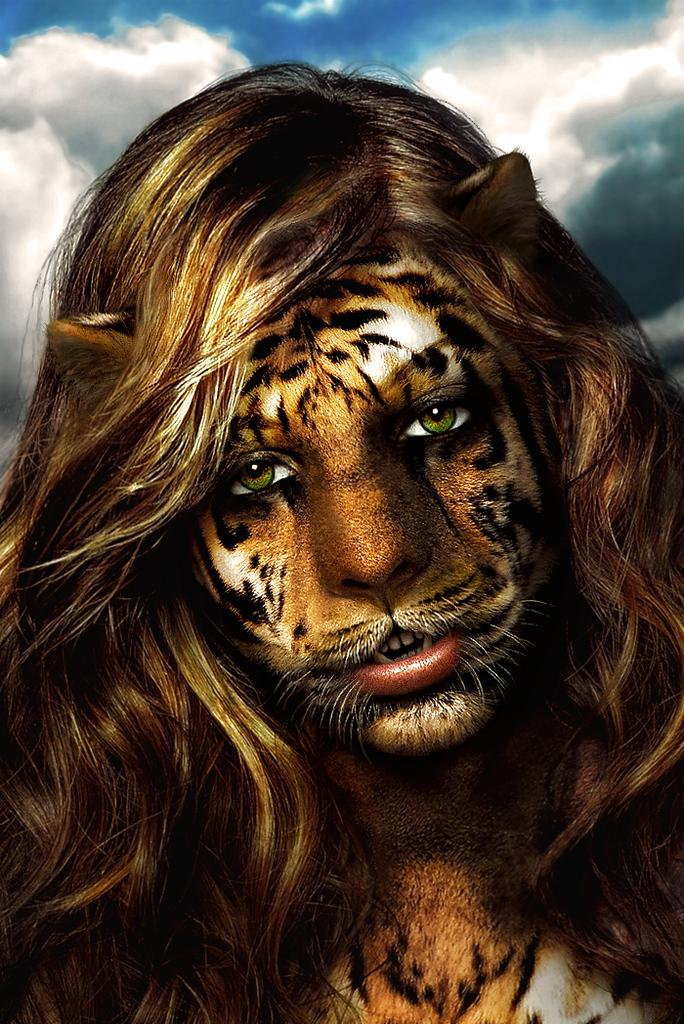What type of editing has been done to the image? The image is edited, but the specific type of editing is not mentioned in the facts. What is the main subject in the center of the image? There is a woman painted on someone's face in the center of the image. What can be seen at the top of the image? The sky is visible at the top of the image. What is present in the sky? Clouds are present in the sky. What date is marked on the calendar in the image? There is no calendar present in the image, so it is not possible to determine the date. 